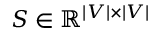<formula> <loc_0><loc_0><loc_500><loc_500>S \in \mathbb { R } ^ { | V | \times | V | }</formula> 